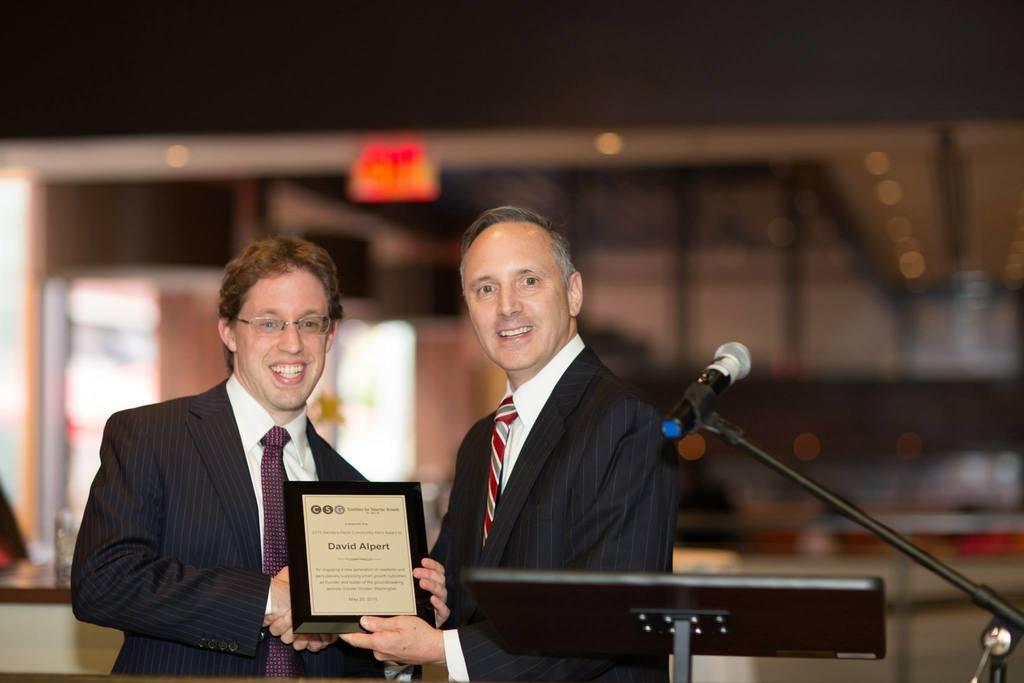Can you describe this image briefly? Here we can see two men holding a frame and they are smiling. There is a mike. And there is a blur background. 